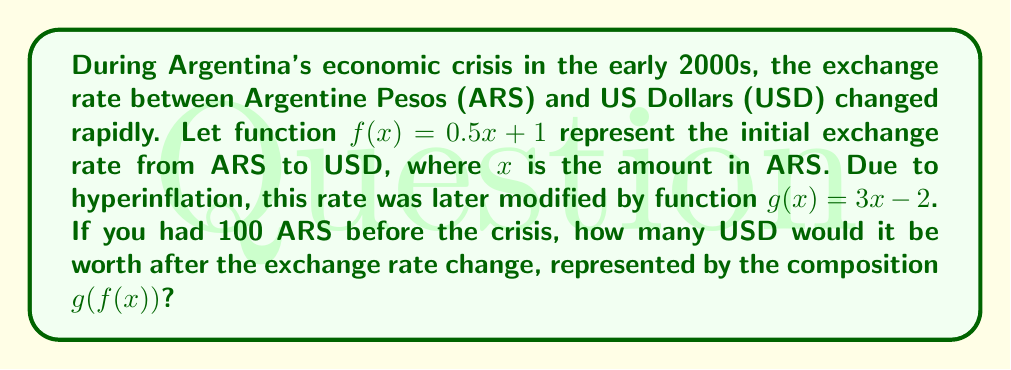Help me with this question. Let's approach this step-by-step:

1) We start with the composition $g(f(x))$. This means we first apply function $f$, then apply $g$ to the result.

2) First, let's calculate $f(100)$:
   $f(100) = 0.5(100) + 1 = 50 + 1 = 51$

3) Now, we need to apply $g$ to this result:
   $g(51) = 3(51) - 2$

4) Let's calculate this:
   $g(51) = 153 - 2 = 151$

5) Therefore, $g(f(100)) = 151$

This means that 100 ARS would be worth 151 USD after the exchange rate change.
Answer: $151 USD 